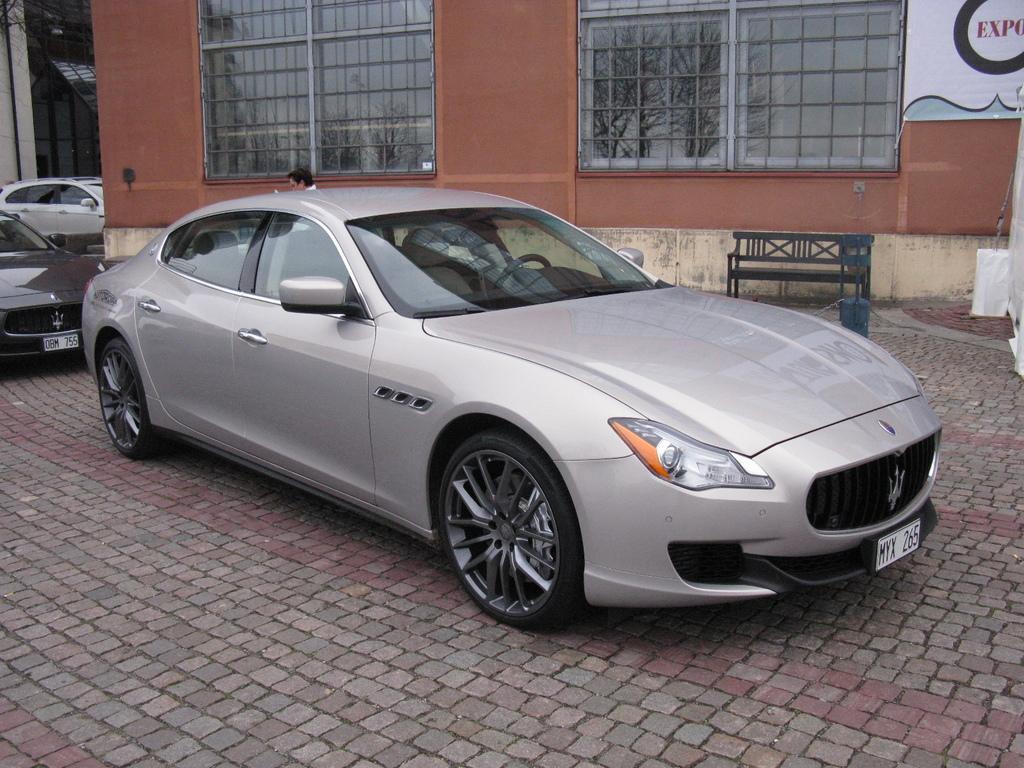How would you summarize this image in a sentence or two? In this image I can see few vehicles and here a person is standing. I can also see a bench and a building. 